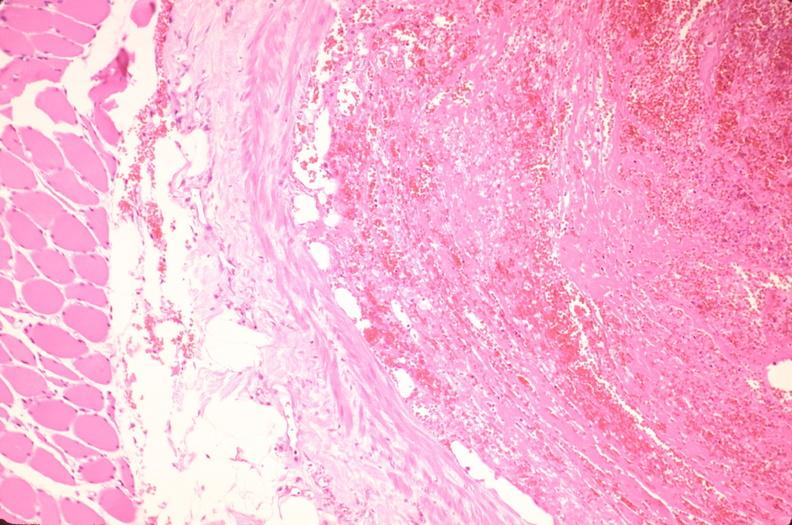s leiomyosarcoma present?
Answer the question using a single word or phrase. No 